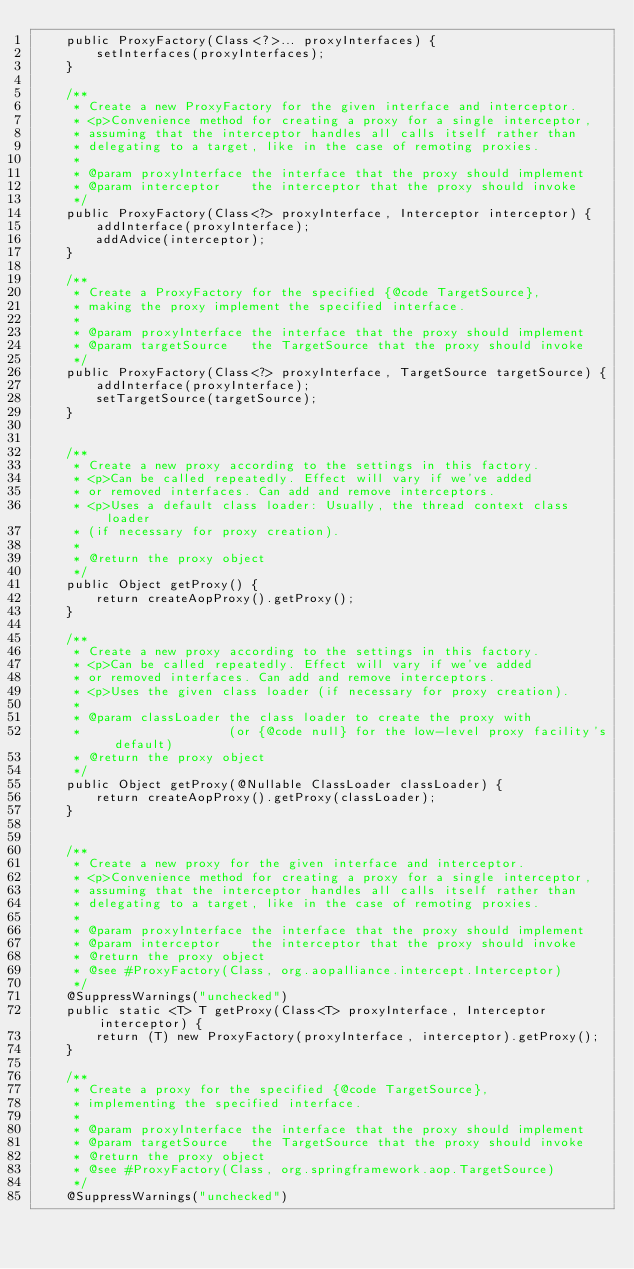<code> <loc_0><loc_0><loc_500><loc_500><_Java_>    public ProxyFactory(Class<?>... proxyInterfaces) {
        setInterfaces(proxyInterfaces);
    }

    /**
     * Create a new ProxyFactory for the given interface and interceptor.
     * <p>Convenience method for creating a proxy for a single interceptor,
     * assuming that the interceptor handles all calls itself rather than
     * delegating to a target, like in the case of remoting proxies.
     *
     * @param proxyInterface the interface that the proxy should implement
     * @param interceptor    the interceptor that the proxy should invoke
     */
    public ProxyFactory(Class<?> proxyInterface, Interceptor interceptor) {
        addInterface(proxyInterface);
        addAdvice(interceptor);
    }

    /**
     * Create a ProxyFactory for the specified {@code TargetSource},
     * making the proxy implement the specified interface.
     *
     * @param proxyInterface the interface that the proxy should implement
     * @param targetSource   the TargetSource that the proxy should invoke
     */
    public ProxyFactory(Class<?> proxyInterface, TargetSource targetSource) {
        addInterface(proxyInterface);
        setTargetSource(targetSource);
    }


    /**
     * Create a new proxy according to the settings in this factory.
     * <p>Can be called repeatedly. Effect will vary if we've added
     * or removed interfaces. Can add and remove interceptors.
     * <p>Uses a default class loader: Usually, the thread context class loader
     * (if necessary for proxy creation).
     *
     * @return the proxy object
     */
    public Object getProxy() {
        return createAopProxy().getProxy();
    }

    /**
     * Create a new proxy according to the settings in this factory.
     * <p>Can be called repeatedly. Effect will vary if we've added
     * or removed interfaces. Can add and remove interceptors.
     * <p>Uses the given class loader (if necessary for proxy creation).
     *
     * @param classLoader the class loader to create the proxy with
     *                    (or {@code null} for the low-level proxy facility's default)
     * @return the proxy object
     */
    public Object getProxy(@Nullable ClassLoader classLoader) {
        return createAopProxy().getProxy(classLoader);
    }


    /**
     * Create a new proxy for the given interface and interceptor.
     * <p>Convenience method for creating a proxy for a single interceptor,
     * assuming that the interceptor handles all calls itself rather than
     * delegating to a target, like in the case of remoting proxies.
     *
     * @param proxyInterface the interface that the proxy should implement
     * @param interceptor    the interceptor that the proxy should invoke
     * @return the proxy object
     * @see #ProxyFactory(Class, org.aopalliance.intercept.Interceptor)
     */
    @SuppressWarnings("unchecked")
    public static <T> T getProxy(Class<T> proxyInterface, Interceptor interceptor) {
        return (T) new ProxyFactory(proxyInterface, interceptor).getProxy();
    }

    /**
     * Create a proxy for the specified {@code TargetSource},
     * implementing the specified interface.
     *
     * @param proxyInterface the interface that the proxy should implement
     * @param targetSource   the TargetSource that the proxy should invoke
     * @return the proxy object
     * @see #ProxyFactory(Class, org.springframework.aop.TargetSource)
     */
    @SuppressWarnings("unchecked")</code> 